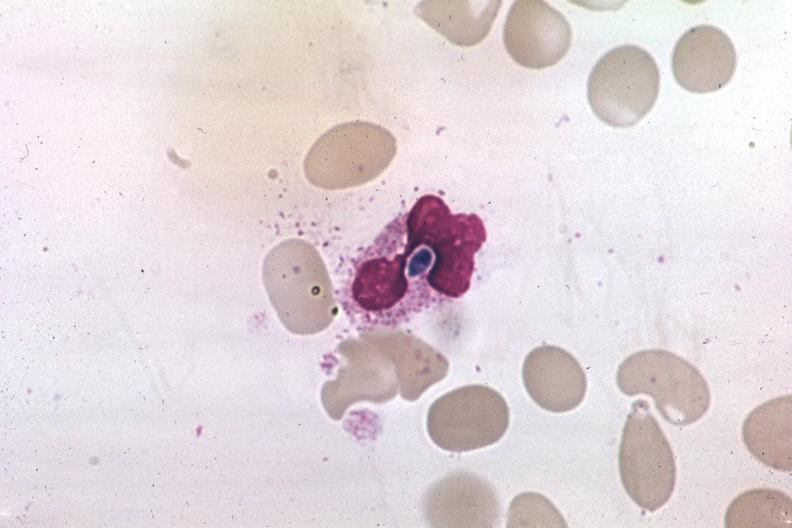what is present?
Answer the question using a single word or phrase. Candida in peripheral blood 